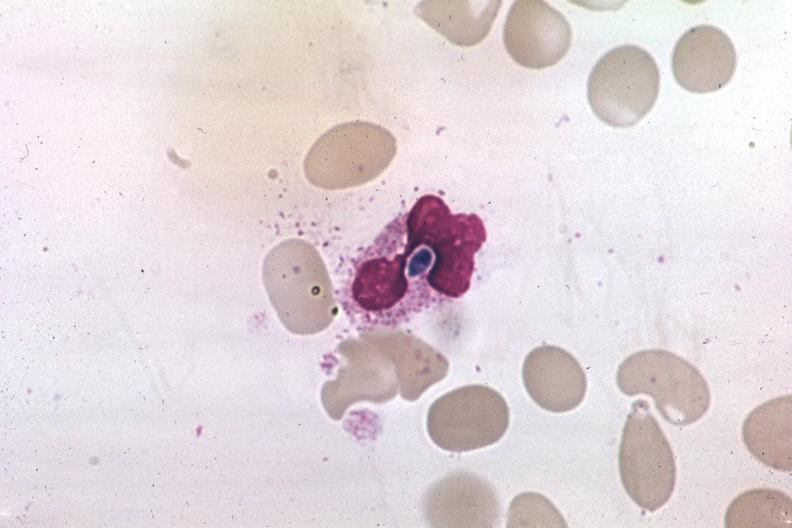what is present?
Answer the question using a single word or phrase. Candida in peripheral blood 